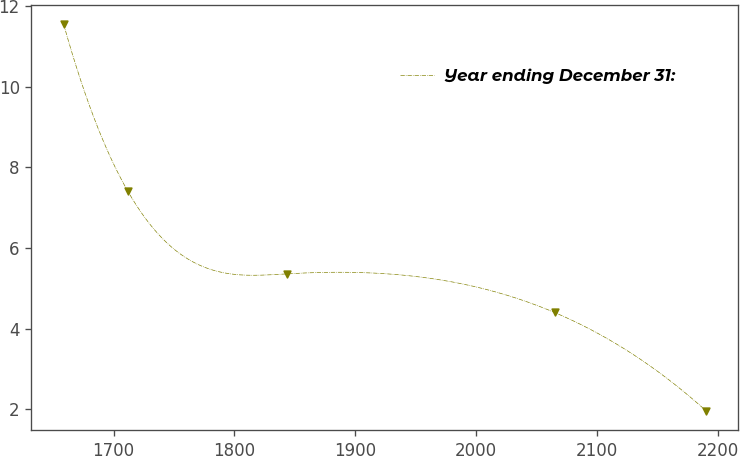Convert chart to OTSL. <chart><loc_0><loc_0><loc_500><loc_500><line_chart><ecel><fcel>Year ending December 31:<nl><fcel>1658.69<fcel>11.56<nl><fcel>1711.83<fcel>7.41<nl><fcel>1843.77<fcel>5.36<nl><fcel>2064.84<fcel>4.4<nl><fcel>2190.13<fcel>1.96<nl></chart> 